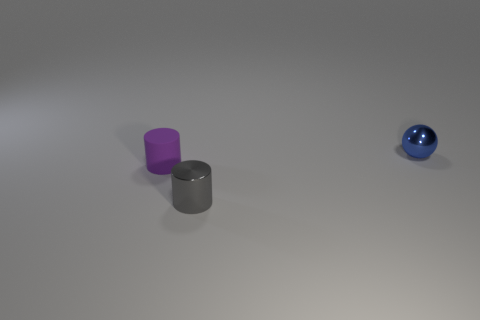Add 3 big gray balls. How many objects exist? 6 Subtract all cylinders. How many objects are left? 1 Subtract 1 balls. How many balls are left? 0 Subtract all small blue balls. Subtract all tiny purple matte cubes. How many objects are left? 2 Add 2 blue metallic balls. How many blue metallic balls are left? 3 Add 3 blue metal spheres. How many blue metal spheres exist? 4 Subtract 0 cyan spheres. How many objects are left? 3 Subtract all yellow spheres. Subtract all blue cubes. How many spheres are left? 1 